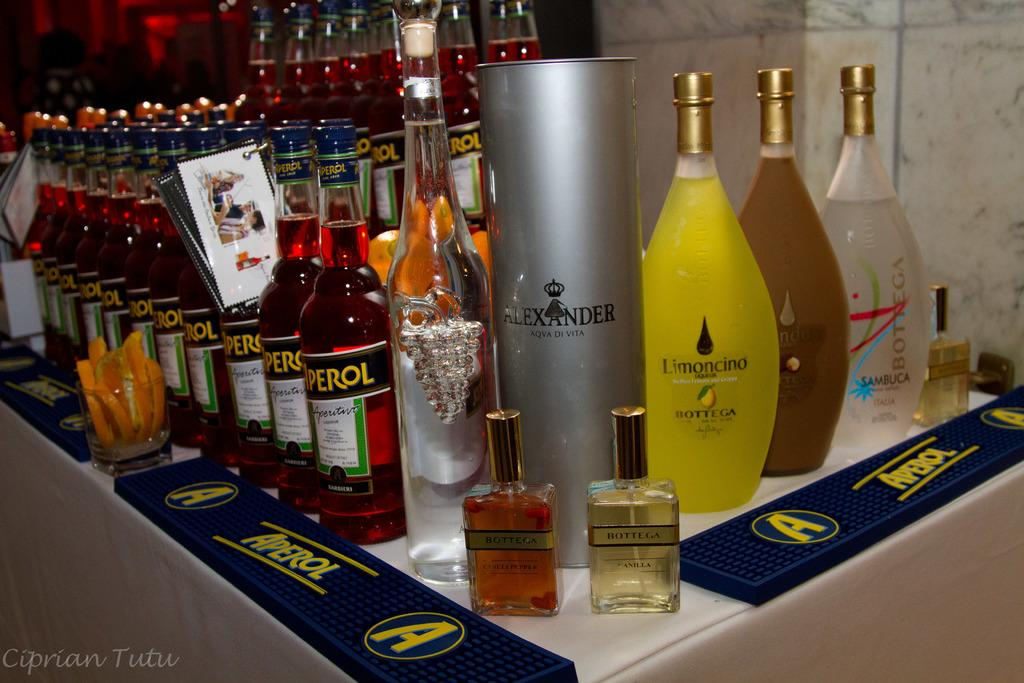What is the main subject of the image? The main subject of the image is many bottles. Where are the bottles located in the image? The bottles are on the floor. What type of silk fabric is draped over the railway in the image? There is no railway or silk fabric present in the image; it only features many bottles on the floor. 